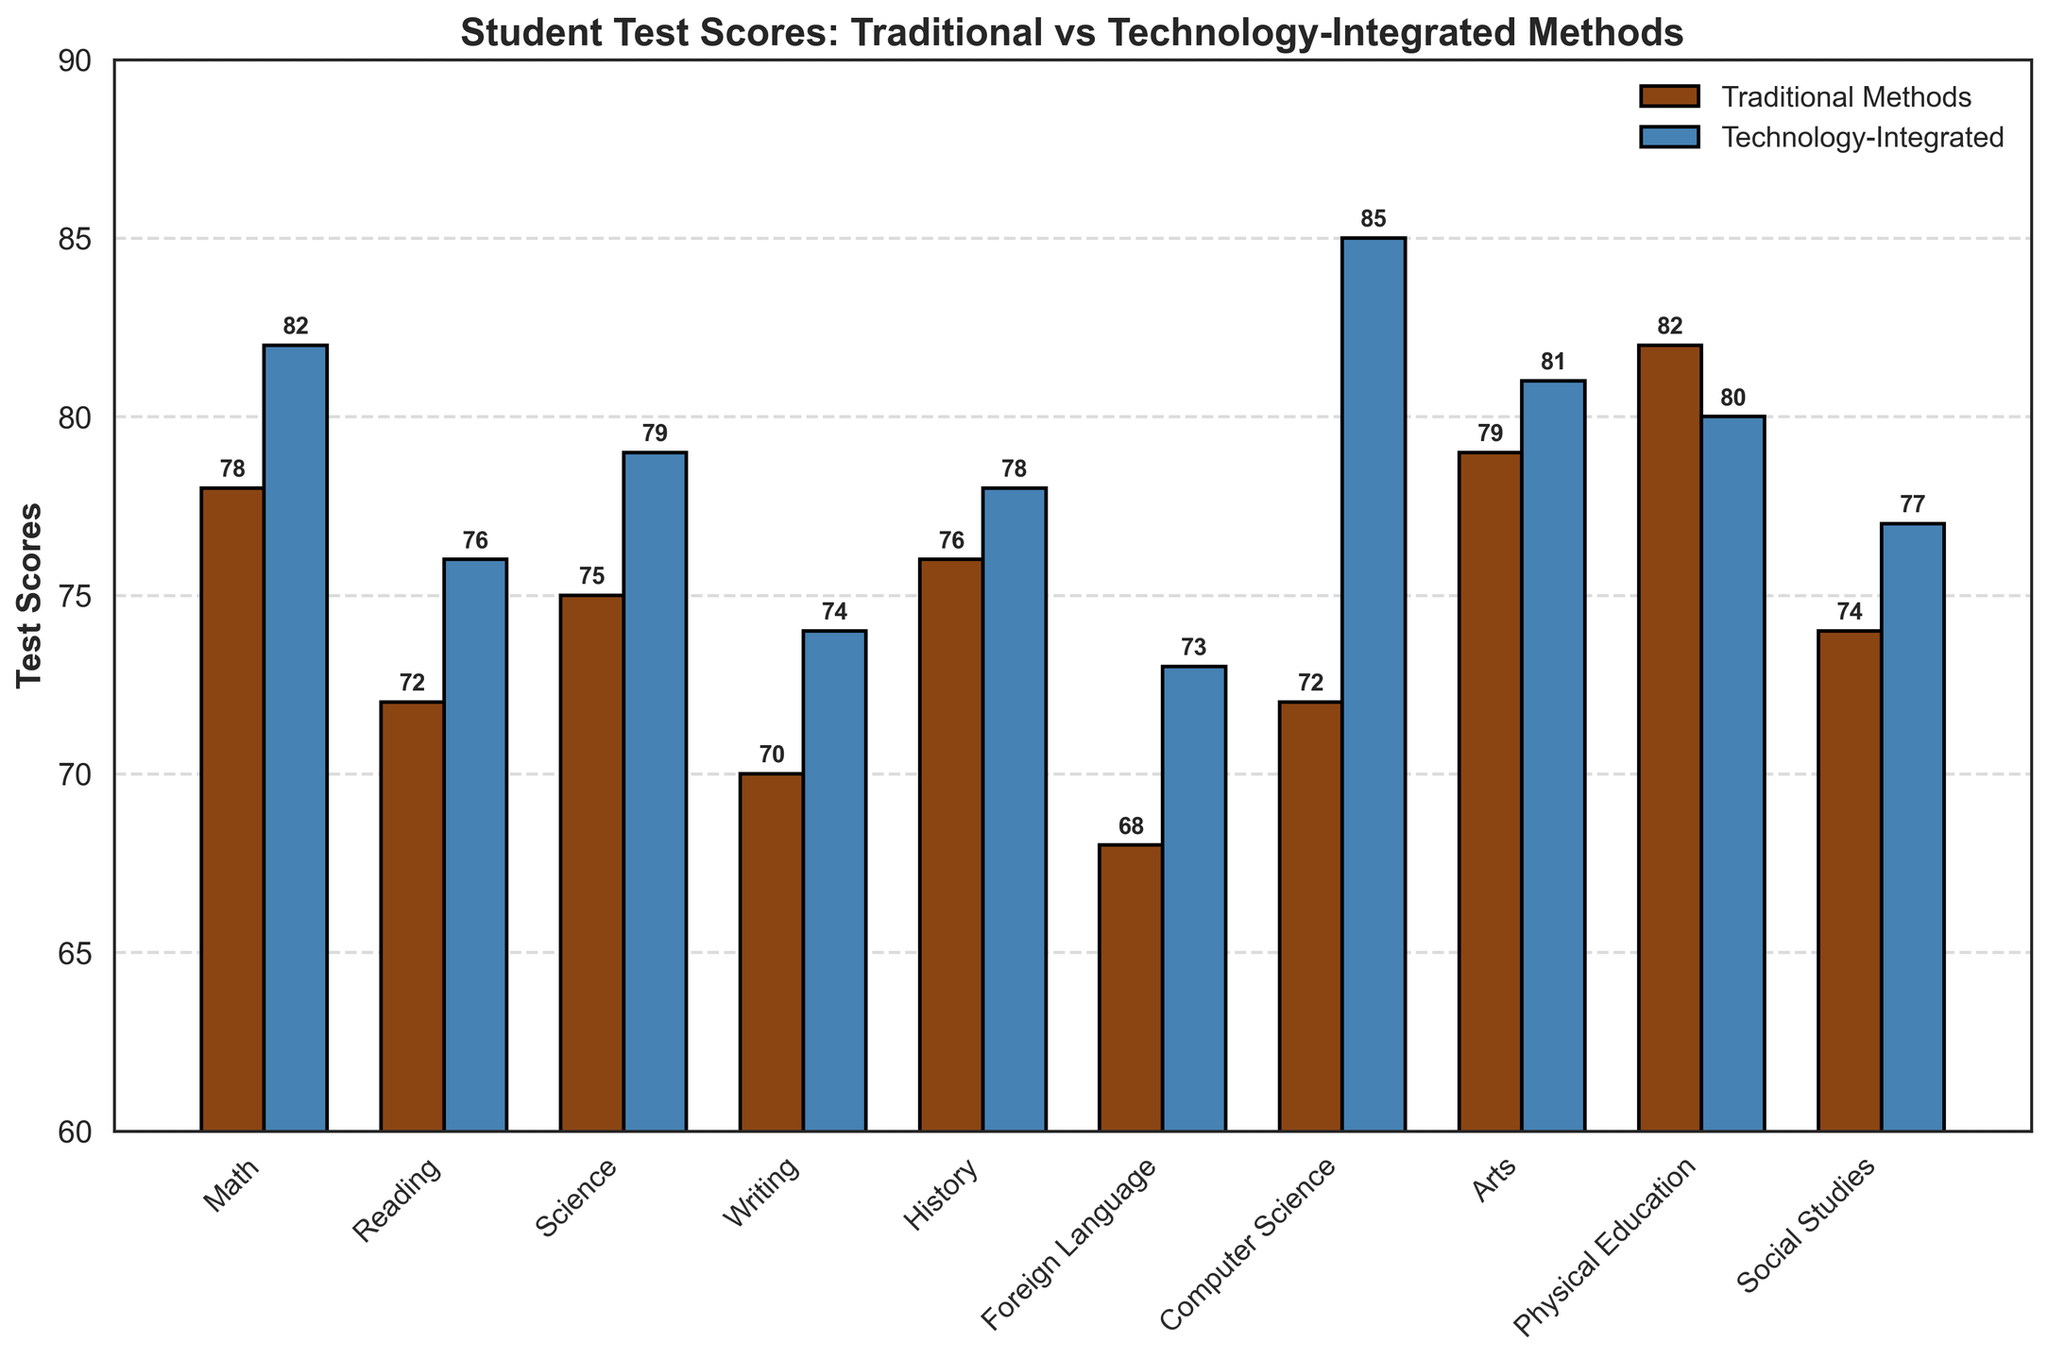What is the title of the bar chart? The title of the bar chart is found at the top and provides an overview of what the chart represents.
Answer: Student Test Scores: Traditional vs Technology-Integrated Methods Which subject has the highest test score using Technology-Integrated methods? To determine this, look at the highest bar in the Technology-Integrated category.
Answer: Computer Science What is the score difference between Traditional Methods and Technology-Integrated for Foreign Language? Subtract the test score for Traditional Methods from the test score for Technology-Integrated in Foreign Language. Calculation: 73 - 68 = 5
Answer: 5 In which subject do Traditional Methods outperform Technology-Integrated methods? Compare the heights of each pair of bars; the subject where the Traditional bar is higher is the answer.
Answer: Physical Education What's the average test score of all subjects using Traditional Methods? Sum up all the test scores using Traditional Methods and divide by the number of subjects. Calculation: (78 + 72 + 75 + 70 + 76 + 68 + 72 + 79 + 82 + 74) / 10 = 74.6
Answer: 74.6 In how many subjects does Technology-Integrated teaching outperform Traditional Methods? Count the subjects where the Technology-Integrated bar is higher than the Traditional Methods bar.
Answer: 8 Which subject has the smallest score difference between the two teaching methods? Calculate the absolute difference for each subject and find the smallest one. Smallest difference is for History: 78 - 76 = 2.
Answer: History Are the test scores consistently higher for Technology-Integrated methods across all subjects? Compare each pair of bars; find any subjects where Traditional Methods outperform.
Answer: No What is the total combined score for Math using both teaching methods? Add the test scores for Math from both teaching methods. Calculation: 78 + 82 = 160
Answer: 160 Which subjects show a score improvement with the use of Technology-Integrated methods compared to Traditional Methods? Compare the scores of both methods for each subject and identify subjects where the Technology-Integrated score is higher.
Answer: Math, Reading, Science, Writing, History, Foreign Language, Computer Science, Arts, Social Studies 